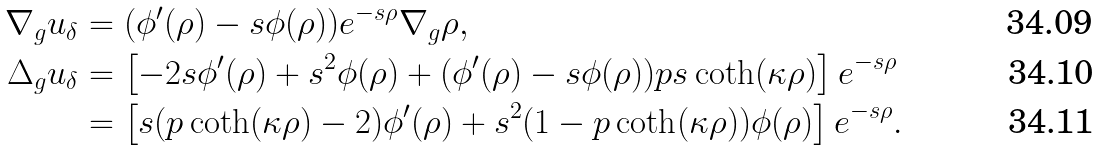<formula> <loc_0><loc_0><loc_500><loc_500>\nabla _ { g } u _ { \delta } & = ( \phi ^ { \prime } ( \rho ) - s \phi ( \rho ) ) e ^ { - s \rho } \nabla _ { g } \rho , \\ \Delta _ { g } u _ { \delta } & = \left [ - 2 s \phi ^ { \prime } ( \rho ) + s ^ { 2 } \phi ( \rho ) + ( \phi ^ { \prime } ( \rho ) - s \phi ( \rho ) ) p s \coth ( \kappa \rho ) \right ] e ^ { - s \rho } \\ & = \left [ s ( p \coth ( \kappa \rho ) - 2 ) \phi ^ { \prime } ( \rho ) + s ^ { 2 } ( 1 - p \coth ( \kappa \rho ) ) \phi ( \rho ) \right ] e ^ { - s \rho } .</formula> 